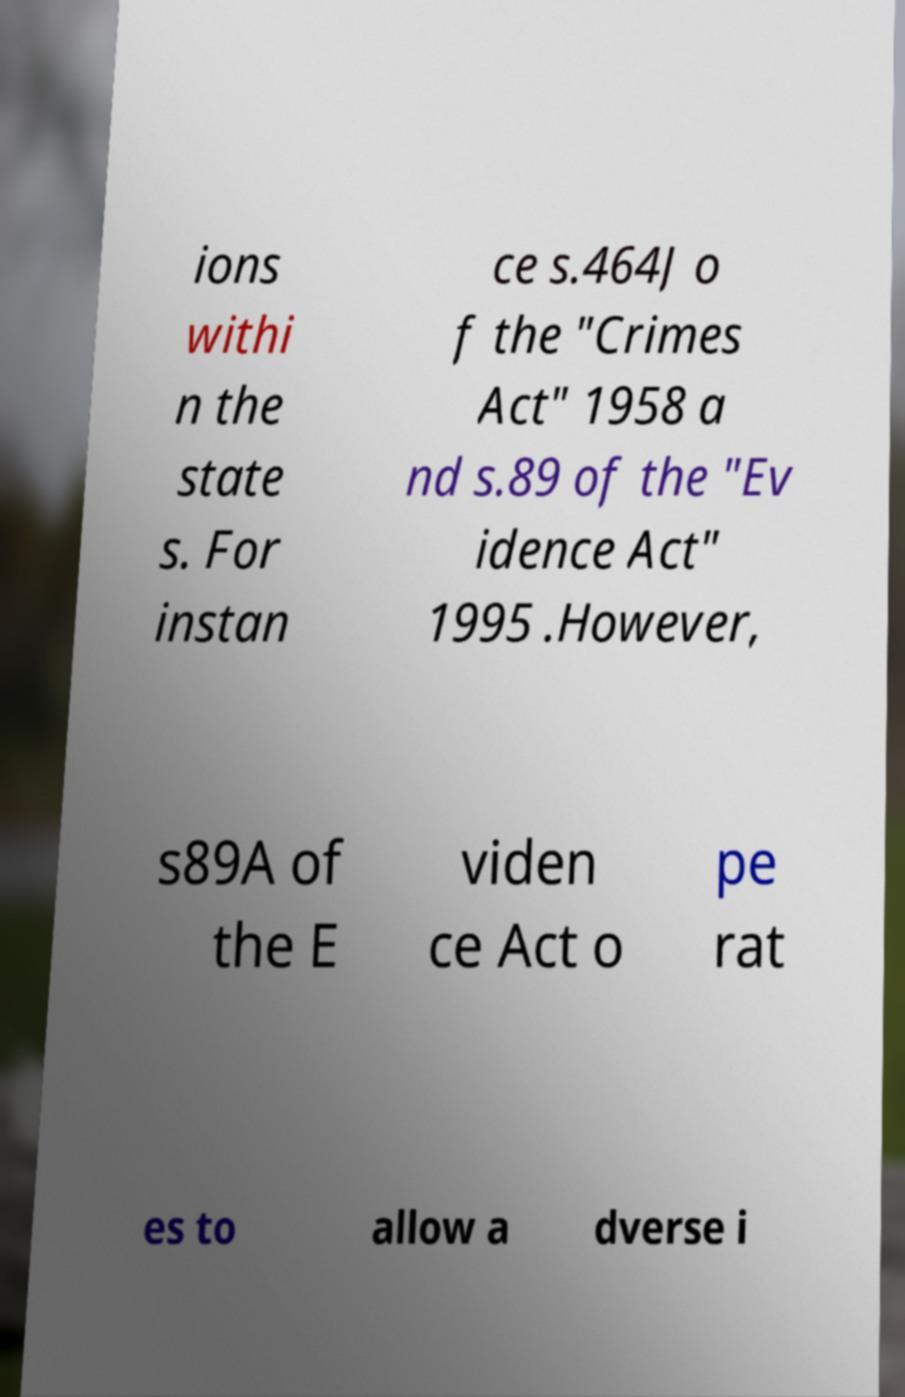There's text embedded in this image that I need extracted. Can you transcribe it verbatim? ions withi n the state s. For instan ce s.464J o f the "Crimes Act" 1958 a nd s.89 of the "Ev idence Act" 1995 .However, s89A of the E viden ce Act o pe rat es to allow a dverse i 